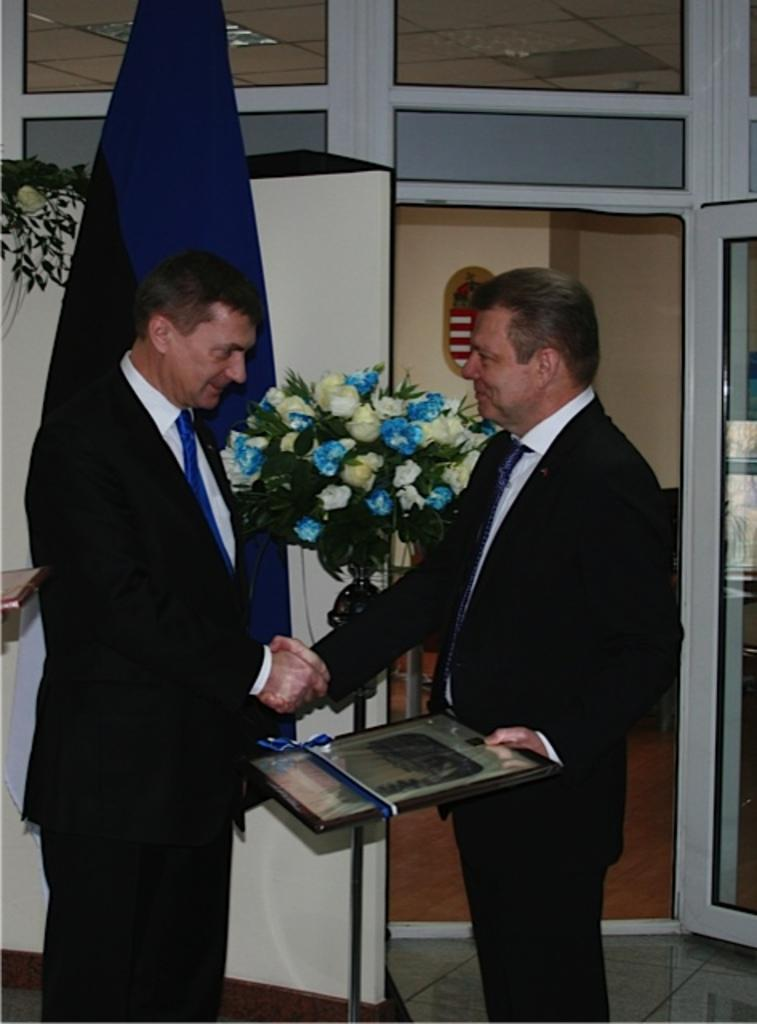How many people are in the image? There are two men in the image. What are the two men doing in the image? The two men are shaking hands. What can be seen in the background of the image? There is a bouquet and a flag in the background of the image. Where is the tent located in the image? There is no tent present in the image. How many houses can be seen in the image? There are no houses visible in the image. 